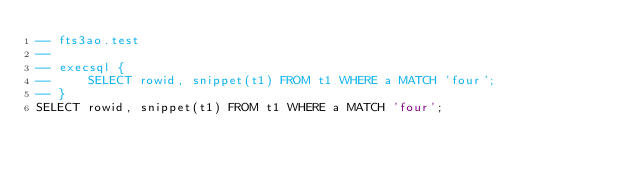<code> <loc_0><loc_0><loc_500><loc_500><_SQL_>-- fts3ao.test
-- 
-- execsql {
--     SELECT rowid, snippet(t1) FROM t1 WHERE a MATCH 'four';
-- }
SELECT rowid, snippet(t1) FROM t1 WHERE a MATCH 'four';</code> 